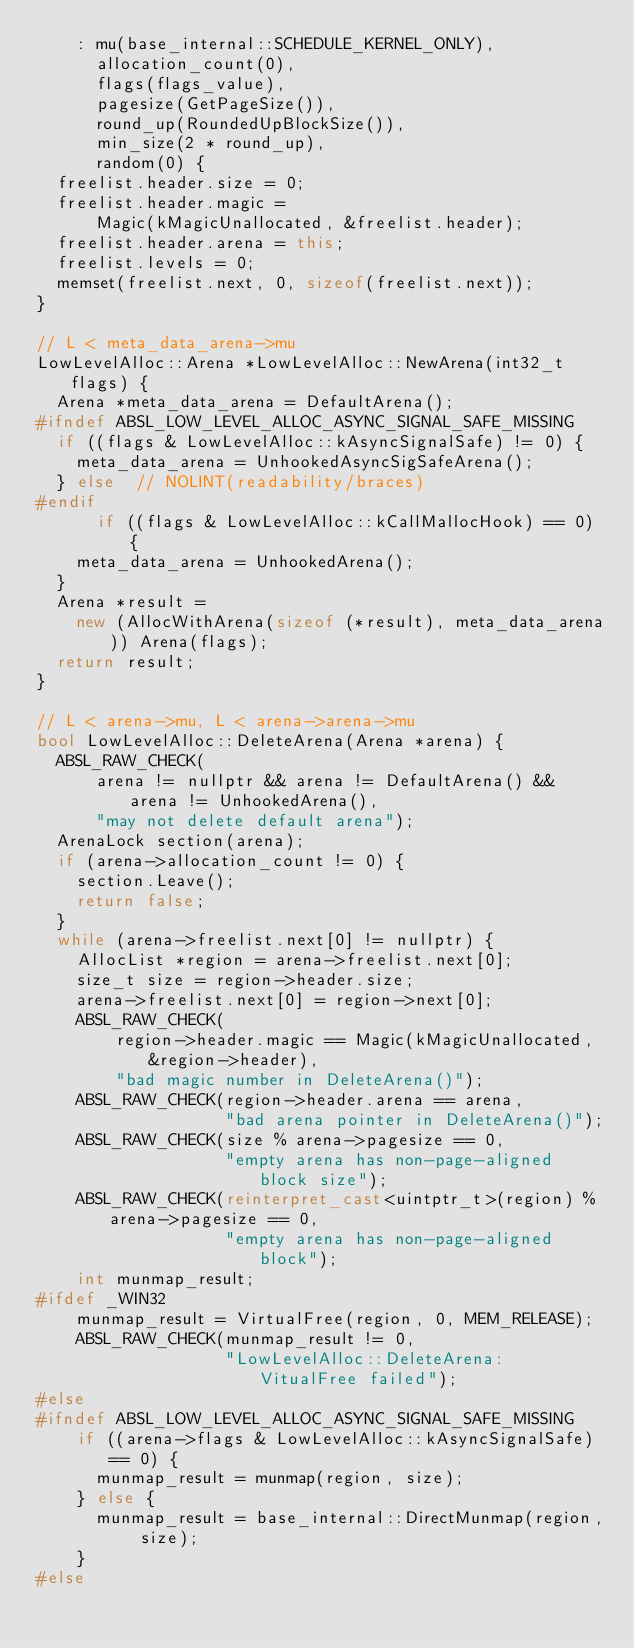Convert code to text. <code><loc_0><loc_0><loc_500><loc_500><_C++_>    : mu(base_internal::SCHEDULE_KERNEL_ONLY),
      allocation_count(0),
      flags(flags_value),
      pagesize(GetPageSize()),
      round_up(RoundedUpBlockSize()),
      min_size(2 * round_up),
      random(0) {
  freelist.header.size = 0;
  freelist.header.magic =
      Magic(kMagicUnallocated, &freelist.header);
  freelist.header.arena = this;
  freelist.levels = 0;
  memset(freelist.next, 0, sizeof(freelist.next));
}

// L < meta_data_arena->mu
LowLevelAlloc::Arena *LowLevelAlloc::NewArena(int32_t flags) {
  Arena *meta_data_arena = DefaultArena();
#ifndef ABSL_LOW_LEVEL_ALLOC_ASYNC_SIGNAL_SAFE_MISSING
  if ((flags & LowLevelAlloc::kAsyncSignalSafe) != 0) {
    meta_data_arena = UnhookedAsyncSigSafeArena();
  } else  // NOLINT(readability/braces)
#endif
      if ((flags & LowLevelAlloc::kCallMallocHook) == 0) {
    meta_data_arena = UnhookedArena();
  }
  Arena *result =
    new (AllocWithArena(sizeof (*result), meta_data_arena)) Arena(flags);
  return result;
}

// L < arena->mu, L < arena->arena->mu
bool LowLevelAlloc::DeleteArena(Arena *arena) {
  ABSL_RAW_CHECK(
      arena != nullptr && arena != DefaultArena() && arena != UnhookedArena(),
      "may not delete default arena");
  ArenaLock section(arena);
  if (arena->allocation_count != 0) {
    section.Leave();
    return false;
  }
  while (arena->freelist.next[0] != nullptr) {
    AllocList *region = arena->freelist.next[0];
    size_t size = region->header.size;
    arena->freelist.next[0] = region->next[0];
    ABSL_RAW_CHECK(
        region->header.magic == Magic(kMagicUnallocated, &region->header),
        "bad magic number in DeleteArena()");
    ABSL_RAW_CHECK(region->header.arena == arena,
                   "bad arena pointer in DeleteArena()");
    ABSL_RAW_CHECK(size % arena->pagesize == 0,
                   "empty arena has non-page-aligned block size");
    ABSL_RAW_CHECK(reinterpret_cast<uintptr_t>(region) % arena->pagesize == 0,
                   "empty arena has non-page-aligned block");
    int munmap_result;
#ifdef _WIN32
    munmap_result = VirtualFree(region, 0, MEM_RELEASE);
    ABSL_RAW_CHECK(munmap_result != 0,
                   "LowLevelAlloc::DeleteArena: VitualFree failed");
#else
#ifndef ABSL_LOW_LEVEL_ALLOC_ASYNC_SIGNAL_SAFE_MISSING
    if ((arena->flags & LowLevelAlloc::kAsyncSignalSafe) == 0) {
      munmap_result = munmap(region, size);
    } else {
      munmap_result = base_internal::DirectMunmap(region, size);
    }
#else</code> 